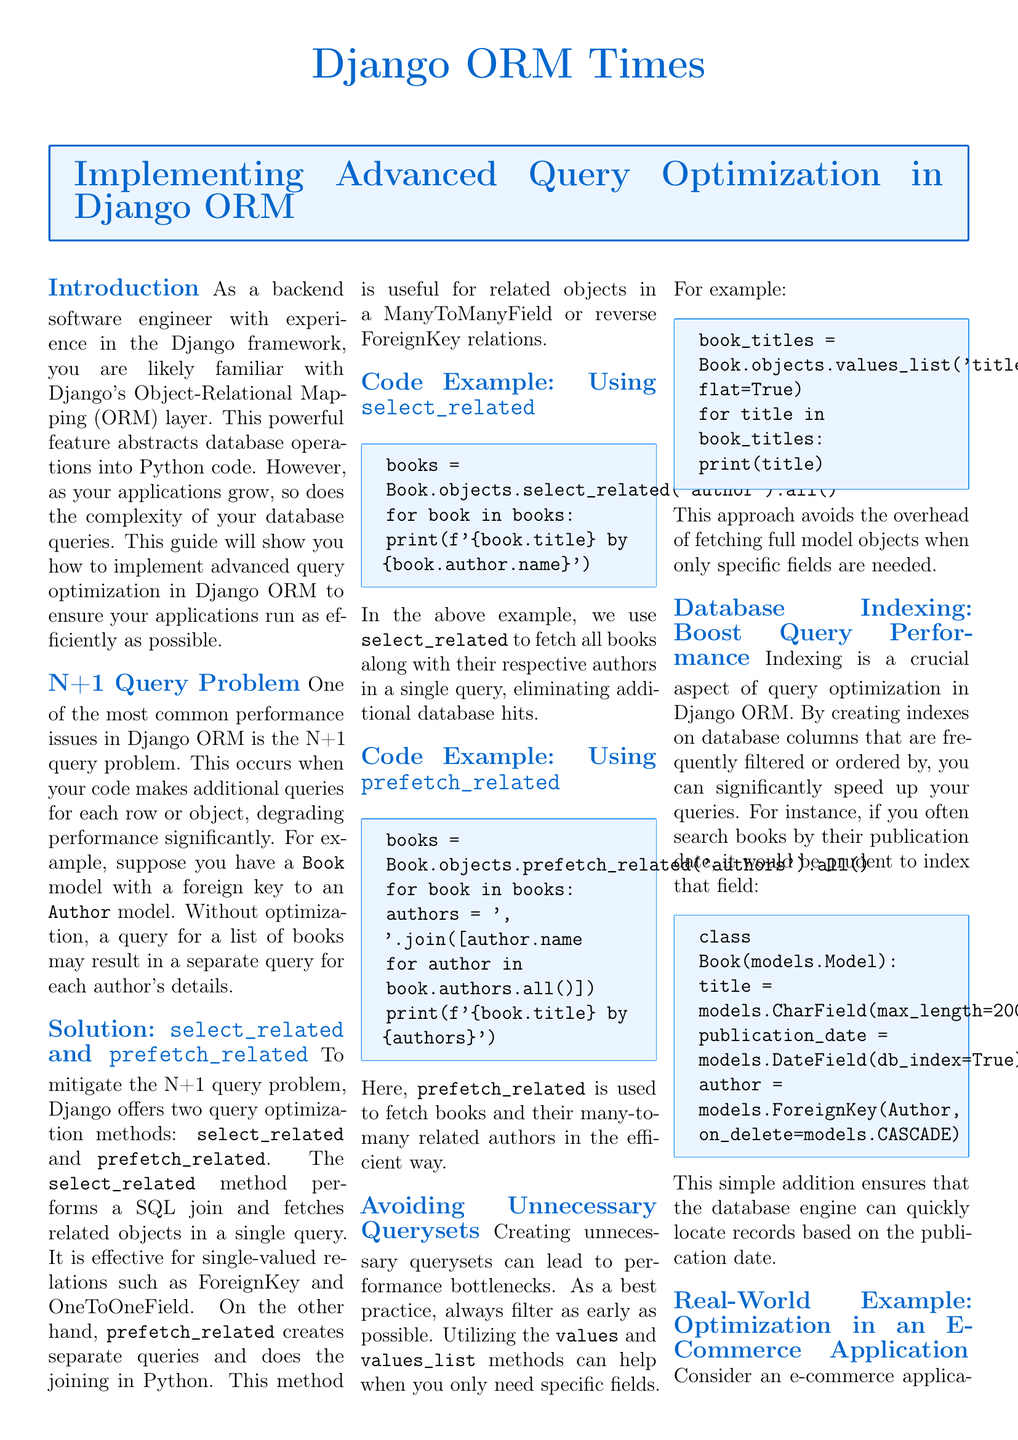What is the title of the document? The title of the document is prominently displayed at the top of the rendered newspaper layout.
Answer: Implementing Advanced Query Optimization in Django ORM What problem is highlighted in the article? The article discusses a specific performance issue that occurs in Django ORM when handling queries.
Answer: N+1 Query Problem Which method performs a SQL join in Django? The document specifies a method that is effective for fetching related objects with a SQL join.
Answer: select_related What code snippet is used to fetch all books along with their authors? The document provides an example showcasing a specific function to retrieve books and authors together.
Answer: books = Book.objects.select_related('author').all() What is the key benefit of adding an index on the publication date? The document addresses how indexing can impact database performance for specific fields in queries.
Answer: Boost Query Performance How does the optimization apply in the e-commerce example? The document uses a particular method to generate a report showing total spending, highlighting how related data is efficiently accessed.
Answer: prefetch_related What is the purpose of using the annotate method in the e-commerce example? The document clarifies the role of a specific method in calculating values based on related data for reporting.
Answer: Adds a calculated field In how many sections does the document present information? The structure of the document indicates the number of distinct content sections provided for the reader's understanding.
Answer: Seven sections 